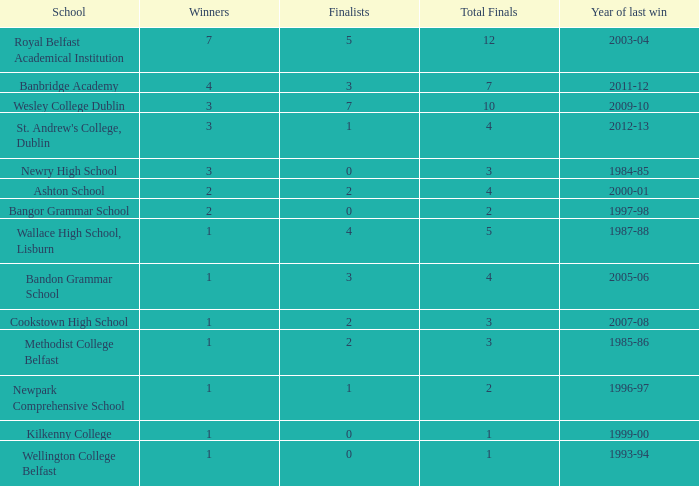What is the designation of the school that had its most recent triumph in 2007-08? Cookstown High School. 